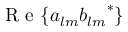<formula> <loc_0><loc_0><loc_500><loc_500>R e \{ a _ { l m } { b _ { l m } } ^ { * } \}</formula> 